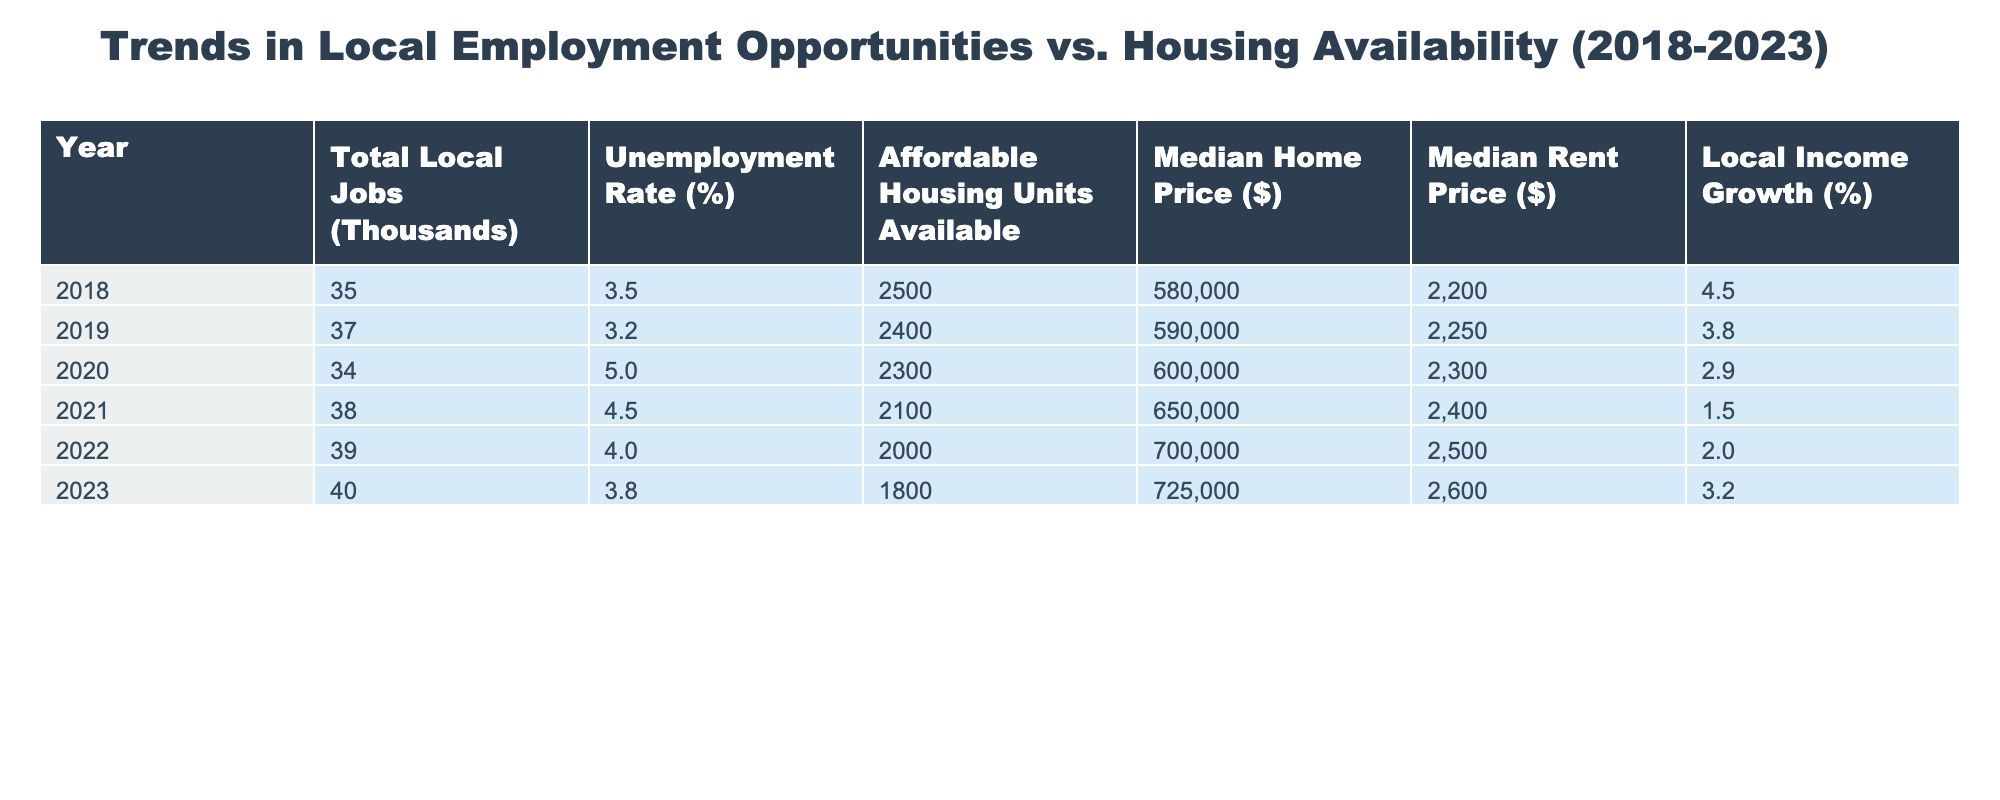What was the total number of local jobs in 2020? Referring to the table, in the year 2020, the value under "Total Local Jobs" is 34 (thousands).
Answer: 34 What was the unemployment rate in 2021? The table indicates the unemployment rate for 2021 is 4.5%.
Answer: 4.5% How many affordable housing units were available in 2023 compared to 2018? In 2023, there were 1800 affordable housing units, and in 2018 there were 2500. The difference is 2500 - 1800 = 700 units.
Answer: 700 What is the change in median home price from 2018 to 2023? The median home price in 2018 is $580,000 and in 2023 is $725,000. The change is $725,000 - $580,000 = $145,000.
Answer: $145,000 Was the local income growth higher in 2019 than in 2022? From the table, local income growth was 3.8% in 2019 and 2.0% in 2022. Since 3.8% is greater than 2.0%, the statement is true.
Answer: Yes In which year was the unemployment rate the highest? By reviewing the unemployment rates from 2018 to 2023, we see that 5.0% in 2020 is the highest value recorded.
Answer: 2020 What is the average number of affordable housing units available from 2018 to 2023? The total affordable housing units over the years are 2500 + 2400 + 2300 + 2100 + 2000 + 1800 = 13,100. There are 6 years, so the average is 13,100 / 6 = approximately 2183.33.
Answer: 2183.33 How much did the median rent price increase from 2018 to 2023? The median rent in 2018 was $2,200 and in 2023 it was $2,600. The increase is $2,600 - $2,200 = $400.
Answer: $400 Which year saw the highest local income growth and what was that percentage? Looking at the local income growth percentages, 2018 had the highest at 4.5%.
Answer: 4.5% Has the availability of affordable housing units decreased continuously from 2018 to 2023? Comparing the data year by year, we see a pattern of decline: 2500 → 2400 → 2300 → 2100 → 2000 → 1800, confirming a continuous decrease.
Answer: Yes 